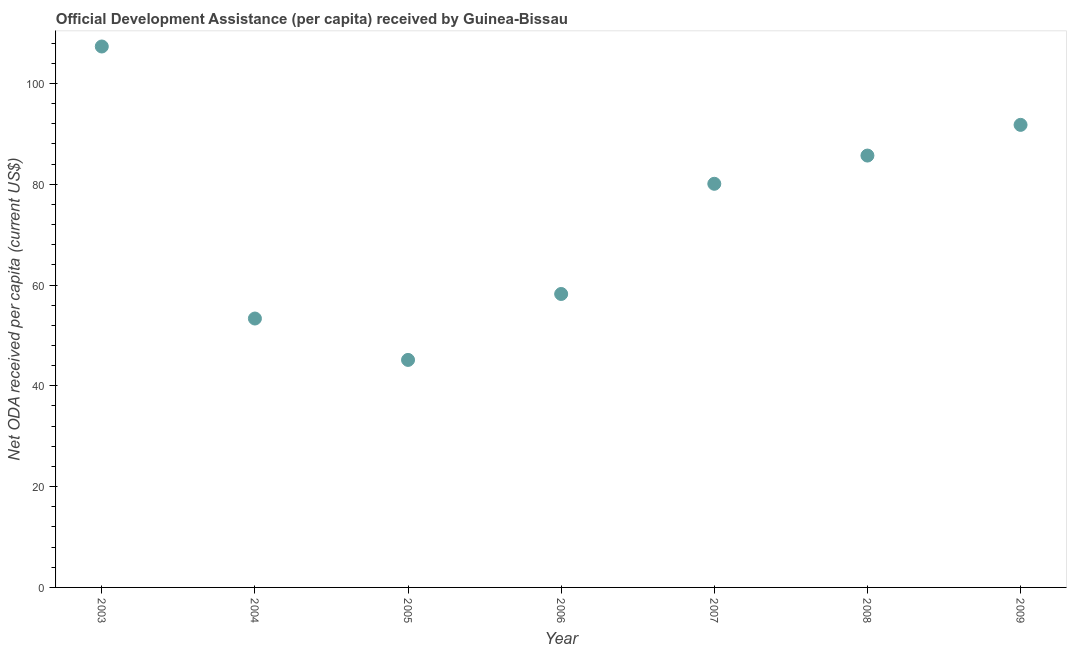What is the net oda received per capita in 2005?
Keep it short and to the point. 45.14. Across all years, what is the maximum net oda received per capita?
Offer a terse response. 107.33. Across all years, what is the minimum net oda received per capita?
Your response must be concise. 45.14. In which year was the net oda received per capita minimum?
Your response must be concise. 2005. What is the sum of the net oda received per capita?
Provide a succinct answer. 521.59. What is the difference between the net oda received per capita in 2005 and 2007?
Offer a very short reply. -34.95. What is the average net oda received per capita per year?
Give a very brief answer. 74.51. What is the median net oda received per capita?
Provide a short and direct response. 80.09. Do a majority of the years between 2009 and 2008 (inclusive) have net oda received per capita greater than 8 US$?
Your answer should be very brief. No. What is the ratio of the net oda received per capita in 2003 to that in 2004?
Make the answer very short. 2.01. Is the net oda received per capita in 2005 less than that in 2006?
Your answer should be very brief. Yes. Is the difference between the net oda received per capita in 2004 and 2005 greater than the difference between any two years?
Your answer should be compact. No. What is the difference between the highest and the second highest net oda received per capita?
Make the answer very short. 15.55. What is the difference between the highest and the lowest net oda received per capita?
Keep it short and to the point. 62.19. In how many years, is the net oda received per capita greater than the average net oda received per capita taken over all years?
Provide a short and direct response. 4. What is the difference between two consecutive major ticks on the Y-axis?
Make the answer very short. 20. Does the graph contain grids?
Make the answer very short. No. What is the title of the graph?
Your answer should be compact. Official Development Assistance (per capita) received by Guinea-Bissau. What is the label or title of the X-axis?
Ensure brevity in your answer.  Year. What is the label or title of the Y-axis?
Your answer should be very brief. Net ODA received per capita (current US$). What is the Net ODA received per capita (current US$) in 2003?
Offer a very short reply. 107.33. What is the Net ODA received per capita (current US$) in 2004?
Provide a short and direct response. 53.35. What is the Net ODA received per capita (current US$) in 2005?
Your answer should be very brief. 45.14. What is the Net ODA received per capita (current US$) in 2006?
Make the answer very short. 58.22. What is the Net ODA received per capita (current US$) in 2007?
Ensure brevity in your answer.  80.09. What is the Net ODA received per capita (current US$) in 2008?
Give a very brief answer. 85.69. What is the Net ODA received per capita (current US$) in 2009?
Offer a very short reply. 91.78. What is the difference between the Net ODA received per capita (current US$) in 2003 and 2004?
Give a very brief answer. 53.97. What is the difference between the Net ODA received per capita (current US$) in 2003 and 2005?
Make the answer very short. 62.19. What is the difference between the Net ODA received per capita (current US$) in 2003 and 2006?
Your answer should be compact. 49.1. What is the difference between the Net ODA received per capita (current US$) in 2003 and 2007?
Your response must be concise. 27.24. What is the difference between the Net ODA received per capita (current US$) in 2003 and 2008?
Your response must be concise. 21.64. What is the difference between the Net ODA received per capita (current US$) in 2003 and 2009?
Provide a succinct answer. 15.55. What is the difference between the Net ODA received per capita (current US$) in 2004 and 2005?
Your answer should be very brief. 8.21. What is the difference between the Net ODA received per capita (current US$) in 2004 and 2006?
Your answer should be compact. -4.87. What is the difference between the Net ODA received per capita (current US$) in 2004 and 2007?
Ensure brevity in your answer.  -26.74. What is the difference between the Net ODA received per capita (current US$) in 2004 and 2008?
Make the answer very short. -32.33. What is the difference between the Net ODA received per capita (current US$) in 2004 and 2009?
Ensure brevity in your answer.  -38.42. What is the difference between the Net ODA received per capita (current US$) in 2005 and 2006?
Offer a terse response. -13.08. What is the difference between the Net ODA received per capita (current US$) in 2005 and 2007?
Ensure brevity in your answer.  -34.95. What is the difference between the Net ODA received per capita (current US$) in 2005 and 2008?
Ensure brevity in your answer.  -40.55. What is the difference between the Net ODA received per capita (current US$) in 2005 and 2009?
Your answer should be very brief. -46.64. What is the difference between the Net ODA received per capita (current US$) in 2006 and 2007?
Provide a short and direct response. -21.86. What is the difference between the Net ODA received per capita (current US$) in 2006 and 2008?
Give a very brief answer. -27.46. What is the difference between the Net ODA received per capita (current US$) in 2006 and 2009?
Offer a very short reply. -33.55. What is the difference between the Net ODA received per capita (current US$) in 2007 and 2008?
Give a very brief answer. -5.6. What is the difference between the Net ODA received per capita (current US$) in 2007 and 2009?
Offer a terse response. -11.69. What is the difference between the Net ODA received per capita (current US$) in 2008 and 2009?
Keep it short and to the point. -6.09. What is the ratio of the Net ODA received per capita (current US$) in 2003 to that in 2004?
Your answer should be compact. 2.01. What is the ratio of the Net ODA received per capita (current US$) in 2003 to that in 2005?
Ensure brevity in your answer.  2.38. What is the ratio of the Net ODA received per capita (current US$) in 2003 to that in 2006?
Your answer should be very brief. 1.84. What is the ratio of the Net ODA received per capita (current US$) in 2003 to that in 2007?
Offer a very short reply. 1.34. What is the ratio of the Net ODA received per capita (current US$) in 2003 to that in 2008?
Your answer should be very brief. 1.25. What is the ratio of the Net ODA received per capita (current US$) in 2003 to that in 2009?
Your response must be concise. 1.17. What is the ratio of the Net ODA received per capita (current US$) in 2004 to that in 2005?
Offer a terse response. 1.18. What is the ratio of the Net ODA received per capita (current US$) in 2004 to that in 2006?
Offer a terse response. 0.92. What is the ratio of the Net ODA received per capita (current US$) in 2004 to that in 2007?
Offer a very short reply. 0.67. What is the ratio of the Net ODA received per capita (current US$) in 2004 to that in 2008?
Make the answer very short. 0.62. What is the ratio of the Net ODA received per capita (current US$) in 2004 to that in 2009?
Keep it short and to the point. 0.58. What is the ratio of the Net ODA received per capita (current US$) in 2005 to that in 2006?
Your answer should be very brief. 0.78. What is the ratio of the Net ODA received per capita (current US$) in 2005 to that in 2007?
Give a very brief answer. 0.56. What is the ratio of the Net ODA received per capita (current US$) in 2005 to that in 2008?
Your answer should be very brief. 0.53. What is the ratio of the Net ODA received per capita (current US$) in 2005 to that in 2009?
Provide a succinct answer. 0.49. What is the ratio of the Net ODA received per capita (current US$) in 2006 to that in 2007?
Your response must be concise. 0.73. What is the ratio of the Net ODA received per capita (current US$) in 2006 to that in 2008?
Provide a short and direct response. 0.68. What is the ratio of the Net ODA received per capita (current US$) in 2006 to that in 2009?
Make the answer very short. 0.63. What is the ratio of the Net ODA received per capita (current US$) in 2007 to that in 2008?
Ensure brevity in your answer.  0.94. What is the ratio of the Net ODA received per capita (current US$) in 2007 to that in 2009?
Make the answer very short. 0.87. What is the ratio of the Net ODA received per capita (current US$) in 2008 to that in 2009?
Give a very brief answer. 0.93. 